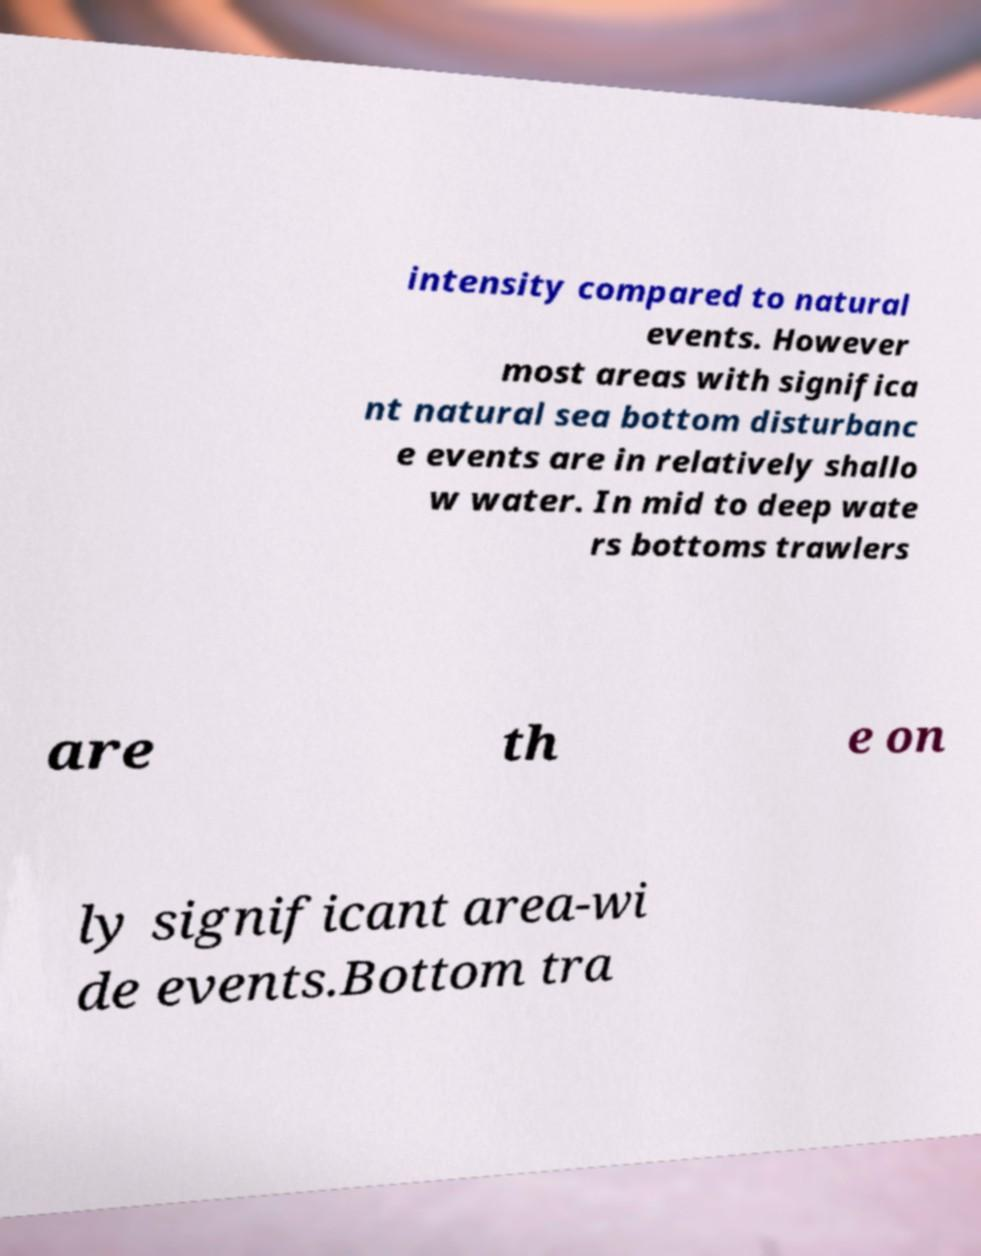Could you assist in decoding the text presented in this image and type it out clearly? intensity compared to natural events. However most areas with significa nt natural sea bottom disturbanc e events are in relatively shallo w water. In mid to deep wate rs bottoms trawlers are th e on ly significant area-wi de events.Bottom tra 